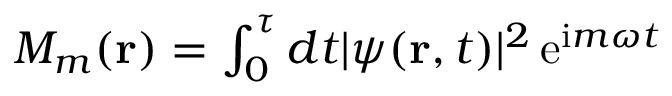Convert formula to latex. <formula><loc_0><loc_0><loc_500><loc_500>\begin{array} { r } { M _ { m } ( { r } ) = \int _ { 0 } ^ { \tau } d t | \psi ( { r } , t ) | ^ { 2 } \, e ^ { i m \omega t } } \end{array}</formula> 